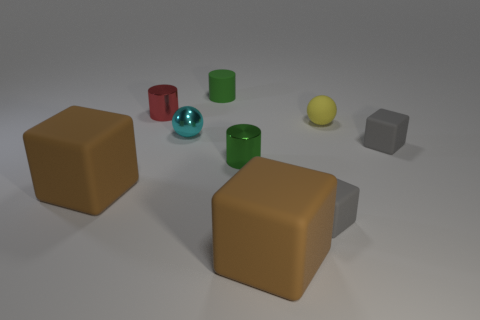Is the yellow object made of the same material as the cyan thing?
Provide a short and direct response. No. There is a small matte object that is both on the left side of the matte sphere and in front of the tiny red metallic cylinder; what color is it?
Ensure brevity in your answer.  Gray. Are there any gray matte cubes of the same size as the rubber sphere?
Offer a very short reply. Yes. What is the size of the rubber thing that is left of the green object that is behind the tiny cyan sphere?
Make the answer very short. Large. Is the number of small yellow things behind the cyan metallic sphere less than the number of tiny cylinders?
Provide a short and direct response. Yes. Is the color of the matte cylinder the same as the tiny matte sphere?
Ensure brevity in your answer.  No. How big is the yellow ball?
Offer a terse response. Small. How many tiny metallic cylinders are the same color as the matte cylinder?
Provide a short and direct response. 1. There is a green shiny cylinder that is behind the gray matte thing to the left of the yellow thing; is there a tiny cube behind it?
Offer a terse response. Yes. There is a red shiny thing that is the same size as the yellow object; what is its shape?
Make the answer very short. Cylinder. 